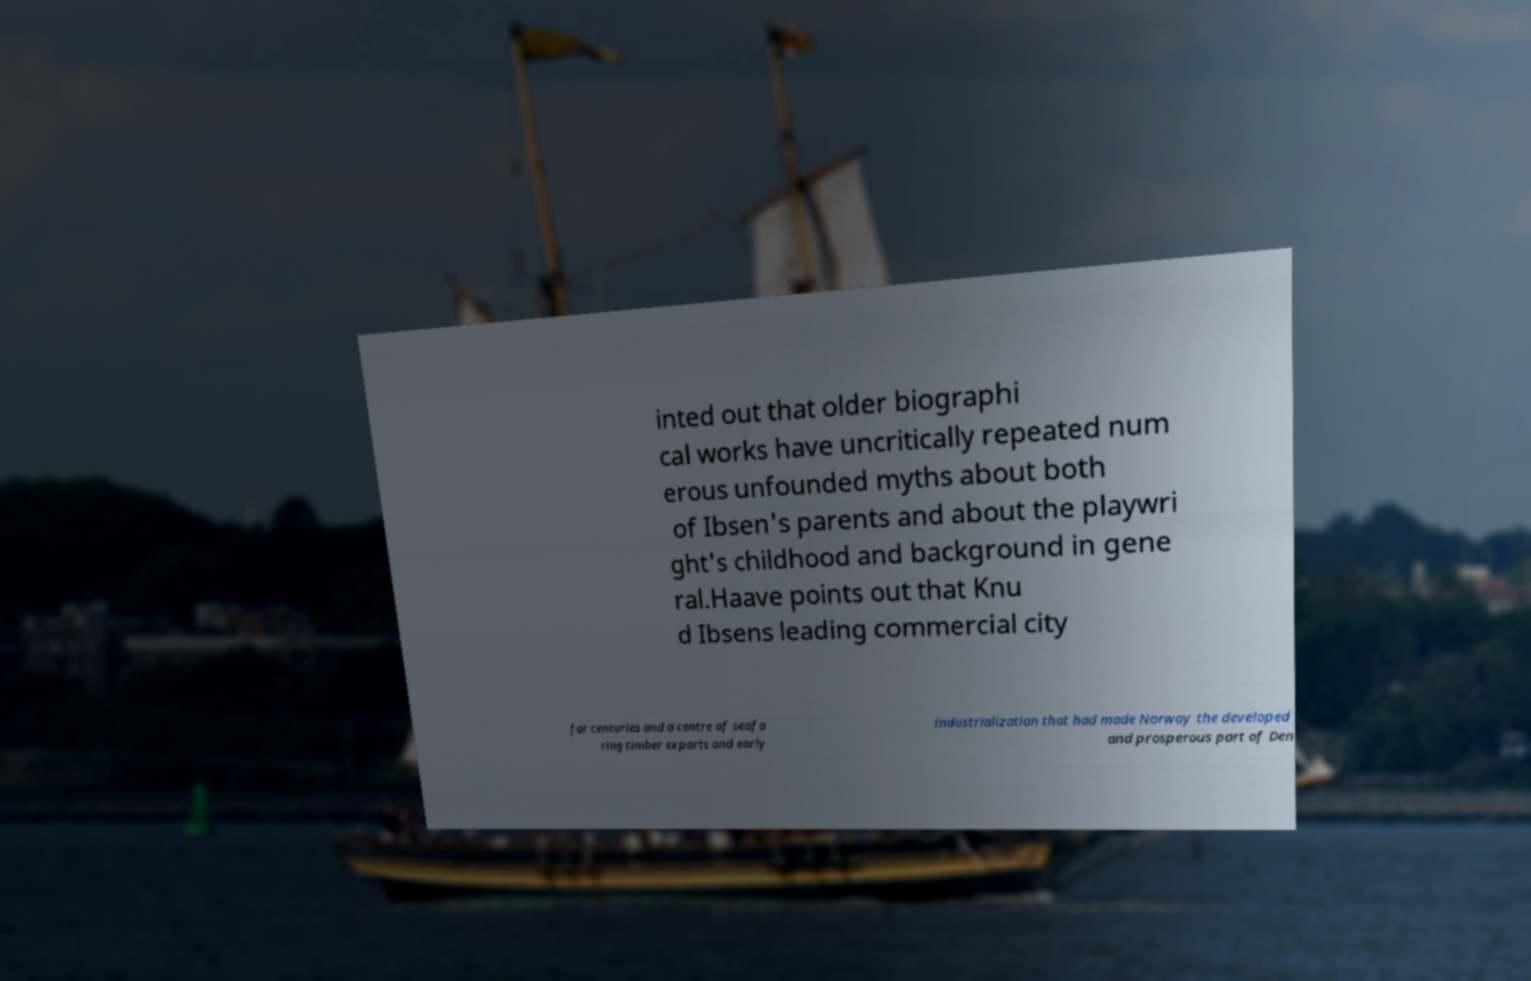Can you accurately transcribe the text from the provided image for me? inted out that older biographi cal works have uncritically repeated num erous unfounded myths about both of Ibsen's parents and about the playwri ght's childhood and background in gene ral.Haave points out that Knu d Ibsens leading commercial city for centuries and a centre of seafa ring timber exports and early industrialization that had made Norway the developed and prosperous part of Den 